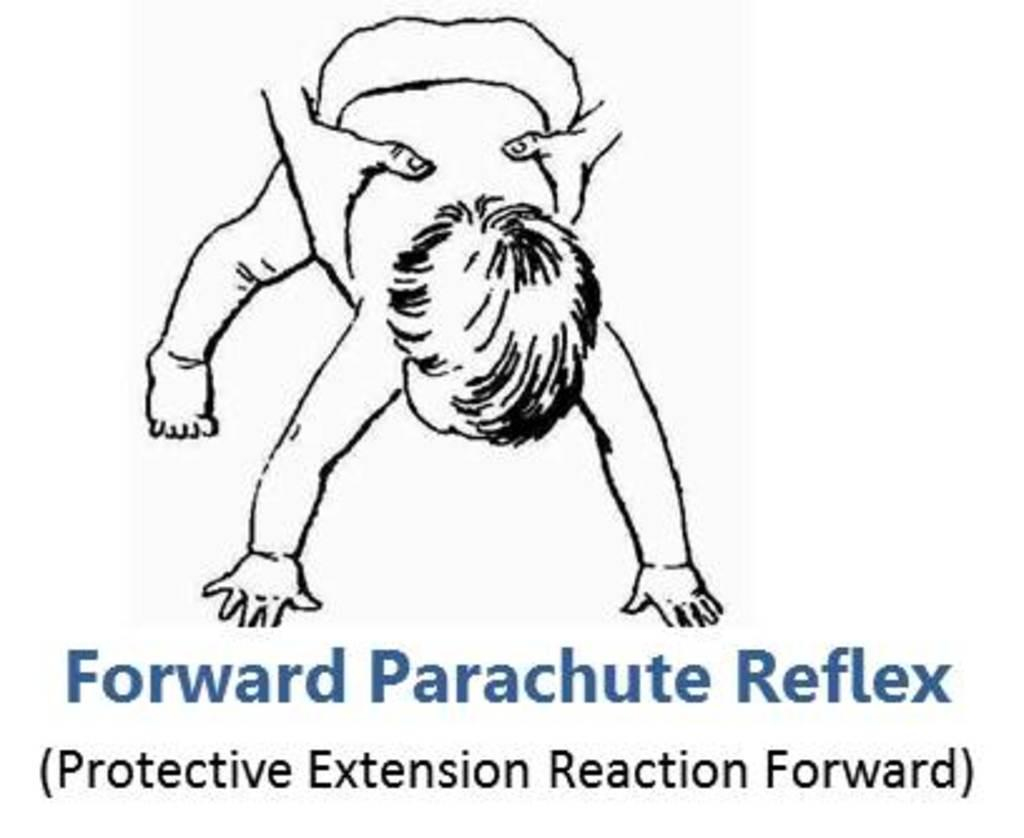What is the color scheme of the image? The image is black and white. What can be seen on the poster in the image? There is a poster with text in the image. What is happening with the baby in the image? Two hands are holding a baby in the image. What type of haircut is the baby getting in the image? There is no haircut happening in the image; the baby is simply being held by two hands. What is the end result of the action involving the baby in the image? The image does not depict a specific end result, as it only shows the baby being held by two hands. 